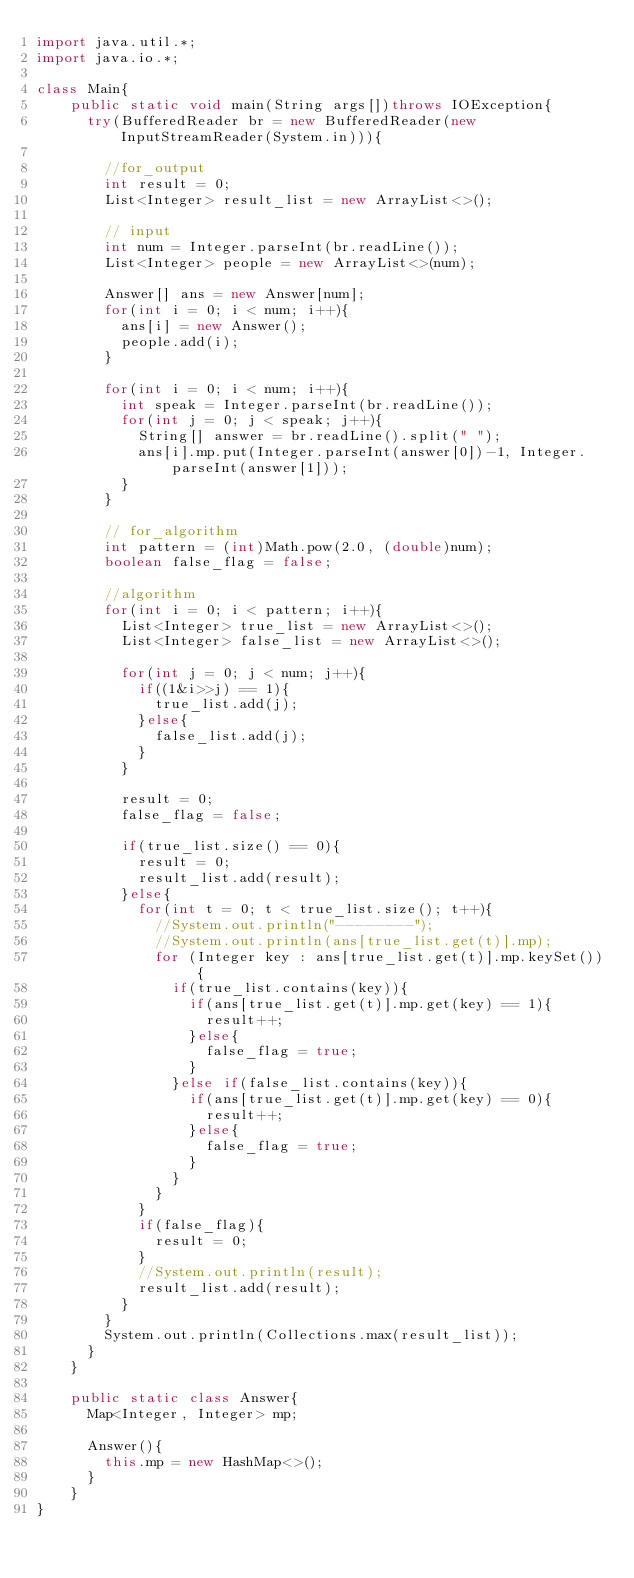Convert code to text. <code><loc_0><loc_0><loc_500><loc_500><_Java_>import java.util.*;
import java.io.*;

class Main{
    public static void main(String args[])throws IOException{
      try(BufferedReader br = new BufferedReader(new InputStreamReader(System.in))){
      
        //for_output
        int result = 0;
        List<Integer> result_list = new ArrayList<>();

        // input
        int num = Integer.parseInt(br.readLine());
        List<Integer> people = new ArrayList<>(num);

        Answer[] ans = new Answer[num];
        for(int i = 0; i < num; i++){
          ans[i] = new Answer();
          people.add(i);
        }

        for(int i = 0; i < num; i++){
          int speak = Integer.parseInt(br.readLine());
          for(int j = 0; j < speak; j++){
            String[] answer = br.readLine().split(" ");
            ans[i].mp.put(Integer.parseInt(answer[0])-1, Integer.parseInt(answer[1]));
          }  
        }

        // for_algorithm
        int pattern = (int)Math.pow(2.0, (double)num);
        boolean false_flag = false;

        //algorithm
        for(int i = 0; i < pattern; i++){
          List<Integer> true_list = new ArrayList<>();
          List<Integer> false_list = new ArrayList<>();
 
          for(int j = 0; j < num; j++){
            if((1&i>>j) == 1){
              true_list.add(j);
            }else{
              false_list.add(j);
            }
          }

          result = 0;
          false_flag = false;

          if(true_list.size() == 0){
            result = 0;
            result_list.add(result);
          }else{
            for(int t = 0; t < true_list.size(); t++){
              //System.out.println("--------");
              //System.out.println(ans[true_list.get(t)].mp);
              for (Integer key : ans[true_list.get(t)].mp.keySet()) {
                if(true_list.contains(key)){
                  if(ans[true_list.get(t)].mp.get(key) == 1){
                    result++;
                  }else{
                    false_flag = true;
                  }
                }else if(false_list.contains(key)){
                  if(ans[true_list.get(t)].mp.get(key) == 0){
                    result++;
                  }else{
                    false_flag = true;
                  }
                }
              }
            }
            if(false_flag){
              result = 0;
            }
            //System.out.println(result);
            result_list.add(result);
          }
        }
        System.out.println(Collections.max(result_list));
      }
    }

    public static class Answer{
      Map<Integer, Integer> mp;

      Answer(){
        this.mp = new HashMap<>();
      }
    } 
}
</code> 